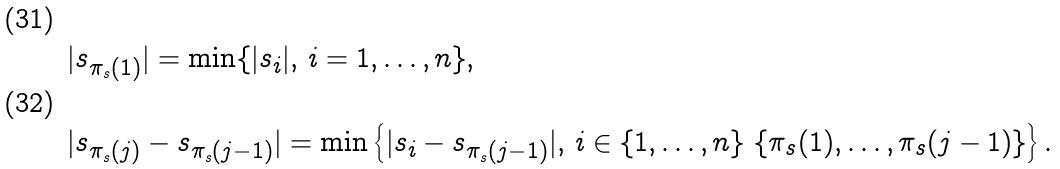Convert formula to latex. <formula><loc_0><loc_0><loc_500><loc_500>& \quad | s _ { \pi _ { s } ( 1 ) } | = \min \{ | s _ { i } | , \, i = 1 , \dots , n \} , \\ & \quad | s _ { \pi _ { s } ( j ) } - s _ { \pi _ { s } ( j - 1 ) } | = \min \left \{ | s _ { i } - s _ { \pi _ { s } ( j - 1 ) } | , \, i \in \{ 1 , \dots , n \} \ \{ \pi _ { s } ( 1 ) , \dots , \pi _ { s } ( j - 1 ) \} \right \} .</formula> 